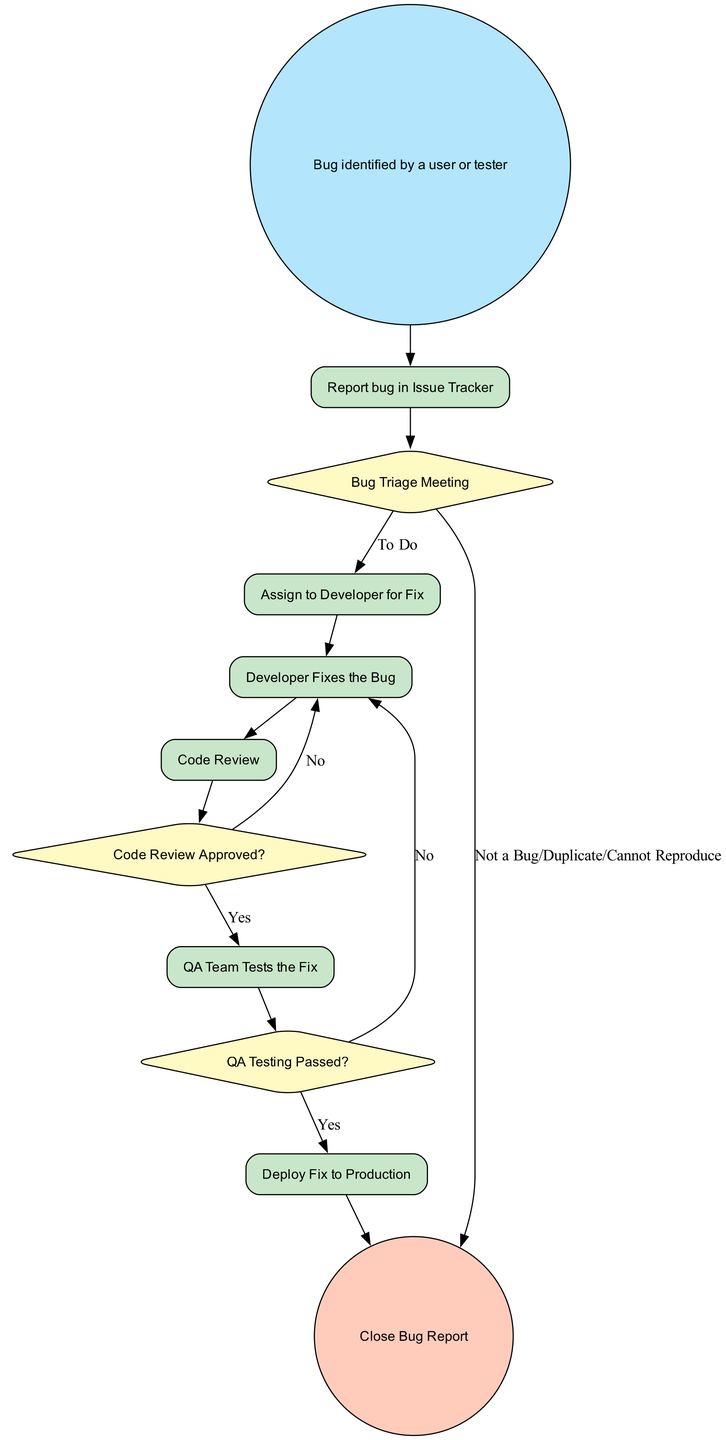What is the first step in the bug reporting process? The first step in the process is represented by the 'start' node, which states that a bug is identified by a user or tester. Therefore, the process begins with a bug being identified.
Answer: Bug identified by a user or tester What task is performed after the bug is reported? After the bug is reported in the Issue Tracker, the next task according to the flow is the Bug Triage Meeting, where the bug is assessed for its next steps.
Answer: Bug Triage Meeting How many decision nodes are in the process? The diagram features three decision nodes: the Bug Triage Meeting, Code Review Approved? and QA Testing Passed?. Therefore, the total count of decision nodes is three.
Answer: 3 What happens if the code review is not approved? If the code review is not approved, the flow indicates that the process returns to fixing the bug. This means the developer must address the issues before resubmitting for review.
Answer: Fix the bug What task follows after QA testing? Following QA testing, the next decision node is QA Testing Passed?. If the tests pass, the next task indicated is to deploy the fix to production.
Answer: Deploy Fix to Production What is the last step of the bug reporting and resolution process? The last step, represented by the 'close' node, indicates that after the fix has been deployed to production, the bug report is closed. This signifies the end of the process.
Answer: Close Bug Report What should be reported in the issue tracker? The required fields to be reported in the issue tracker include Bug Title, Description, Steps to Reproduce, Severity, and Screenshot/Logs. These elements must be filled out to properly report the bug.
Answer: Bug Title, Description, Steps to Reproduce, Severity, Screenshot/Logs If a bug is categorized as "Not a Bug," what is the next action? If the bug is categorized as "Not a Bug" during the Bug Triage Meeting, the process flows directly to closing the bug report, indicating no further action is required.
Answer: Close Bug Report 